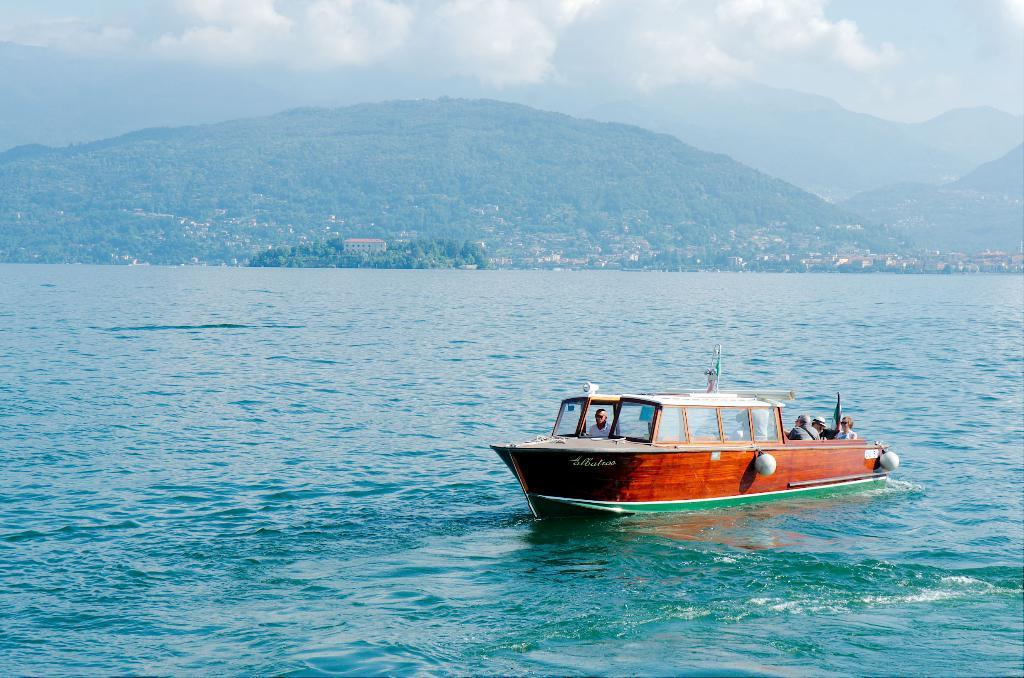What is the main subject of the image? The main subject of the image is a boat. Where is the boat located? The boat is on the water. Are there any people on the boat? Yes, there are people on the boat. What can be seen in the background of the image? In the background of the image, there are houses, trees, a mountain, and the sky. What is the condition of the sky in the image? The sky is visible in the background of the image, and clouds are present. Can you see the nest of the bird in the image? There is no bird or nest present in the image. What color are the eyes of the person on the boat? The image does not provide enough detail to determine the color of the people's eyes on the boat. 